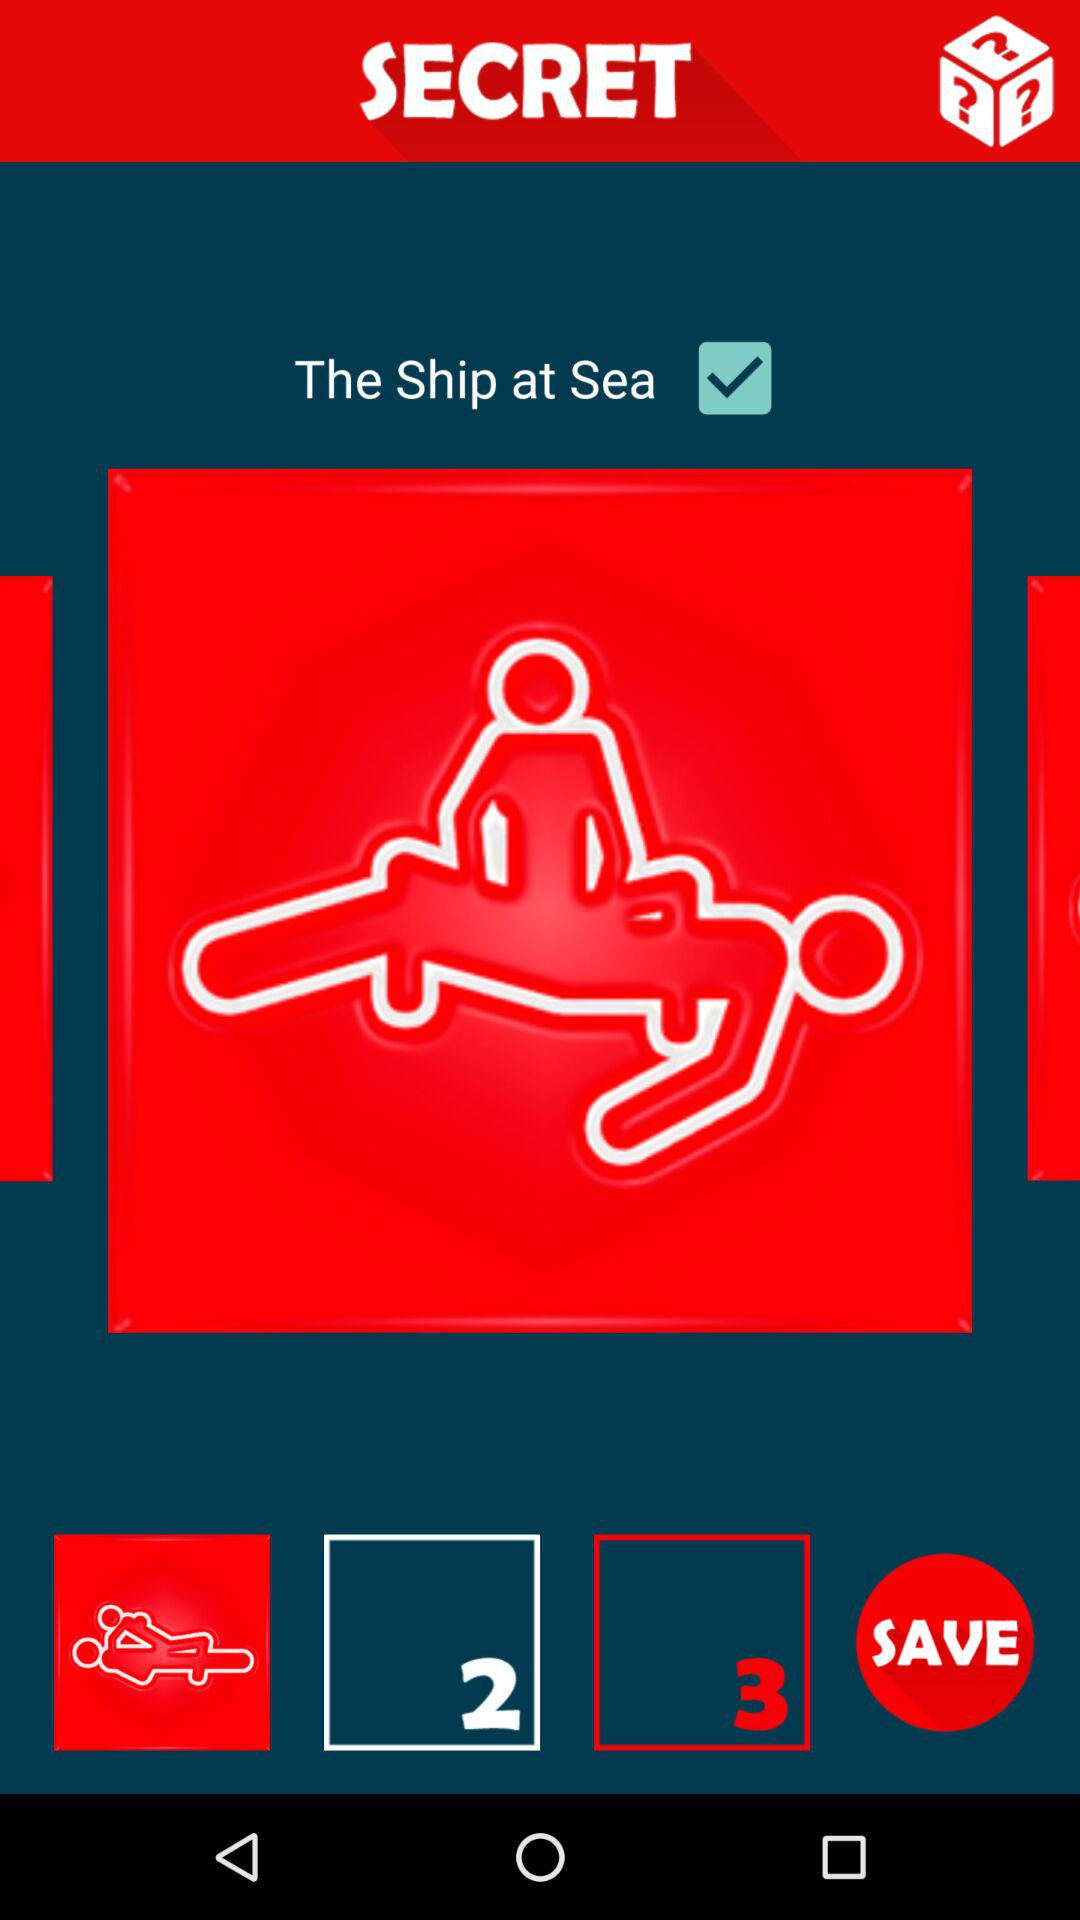What is the name of the application? The name of the application is "SECRET". 